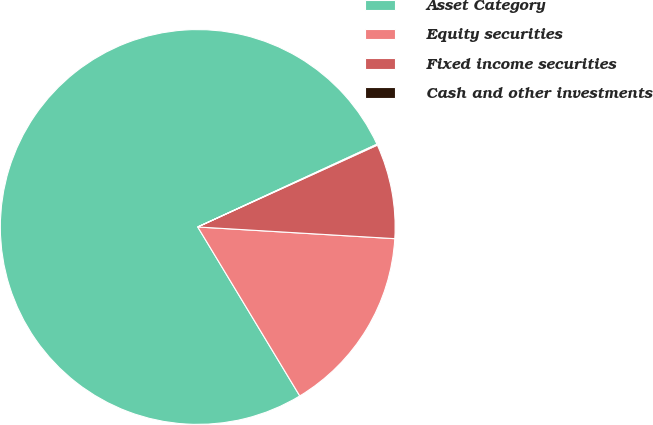<chart> <loc_0><loc_0><loc_500><loc_500><pie_chart><fcel>Asset Category<fcel>Equity securities<fcel>Fixed income securities<fcel>Cash and other investments<nl><fcel>76.76%<fcel>15.41%<fcel>7.75%<fcel>0.08%<nl></chart> 